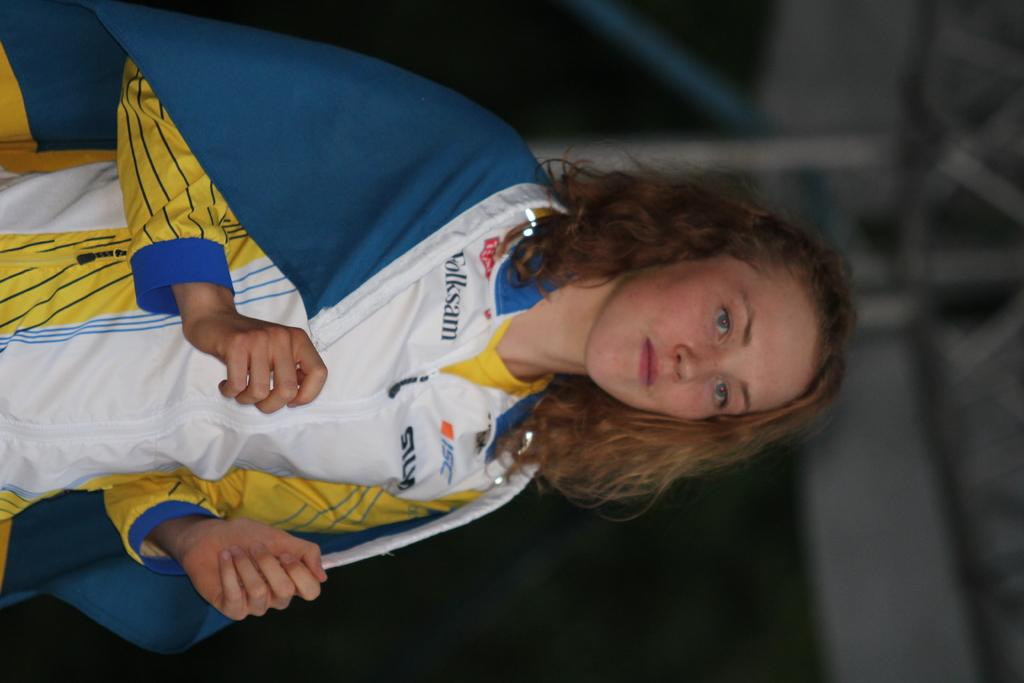What does her shirt say?
Your response must be concise. Folksam. 